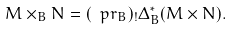<formula> <loc_0><loc_0><loc_500><loc_500>M \times _ { B } N = ( \ p r _ { B } ) _ { ! } \Delta _ { B } ^ { * } ( M \times N ) .</formula> 